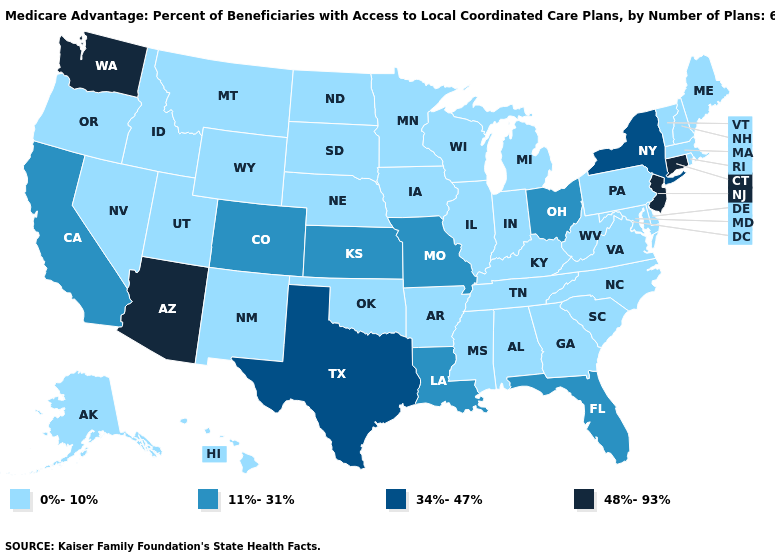Which states have the lowest value in the West?
Write a very short answer. Alaska, Hawaii, Idaho, Montana, New Mexico, Nevada, Oregon, Utah, Wyoming. Among the states that border New Jersey , which have the lowest value?
Write a very short answer. Delaware, Pennsylvania. What is the highest value in states that border Missouri?
Answer briefly. 11%-31%. What is the highest value in the USA?
Answer briefly. 48%-93%. Among the states that border Michigan , which have the lowest value?
Be succinct. Indiana, Wisconsin. What is the value of Illinois?
Short answer required. 0%-10%. Name the states that have a value in the range 11%-31%?
Be succinct. California, Colorado, Florida, Kansas, Louisiana, Missouri, Ohio. How many symbols are there in the legend?
Write a very short answer. 4. What is the value of South Dakota?
Quick response, please. 0%-10%. Does the map have missing data?
Short answer required. No. Among the states that border Kentucky , does Ohio have the lowest value?
Concise answer only. No. What is the lowest value in states that border South Carolina?
Short answer required. 0%-10%. Which states hav the highest value in the MidWest?
Short answer required. Kansas, Missouri, Ohio. Which states have the highest value in the USA?
Give a very brief answer. Arizona, Connecticut, New Jersey, Washington. Does Delaware have the same value as Texas?
Keep it brief. No. 